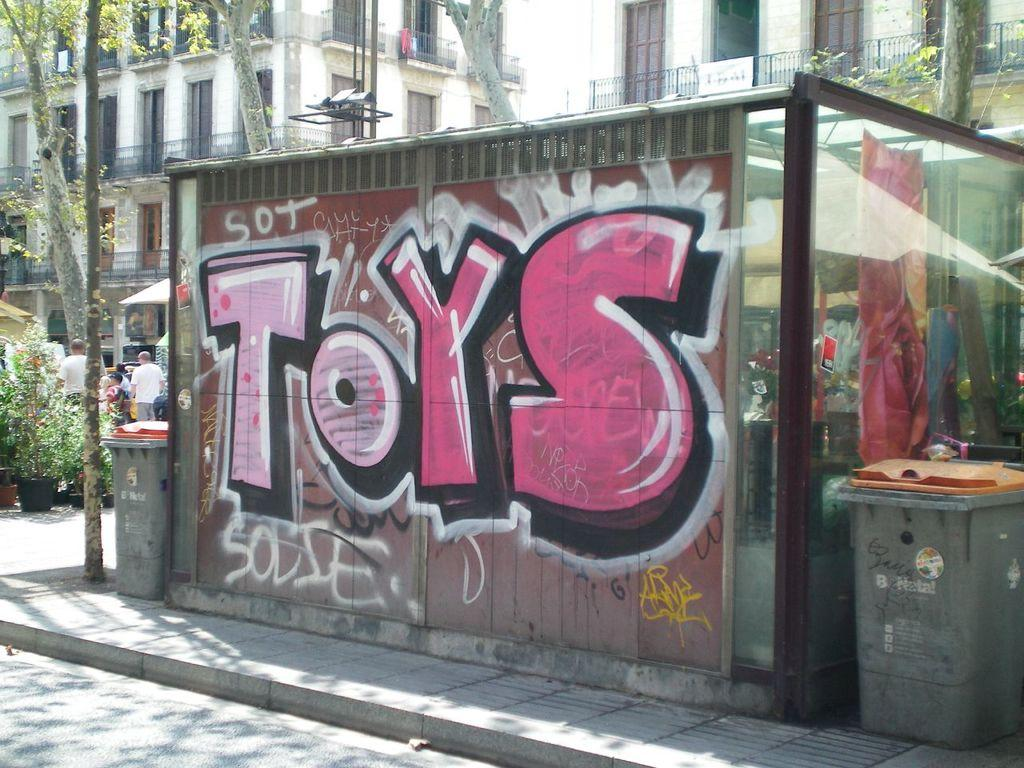<image>
Provide a brief description of the given image. A greenhouse on a city street is spray painted with the word Toys. 